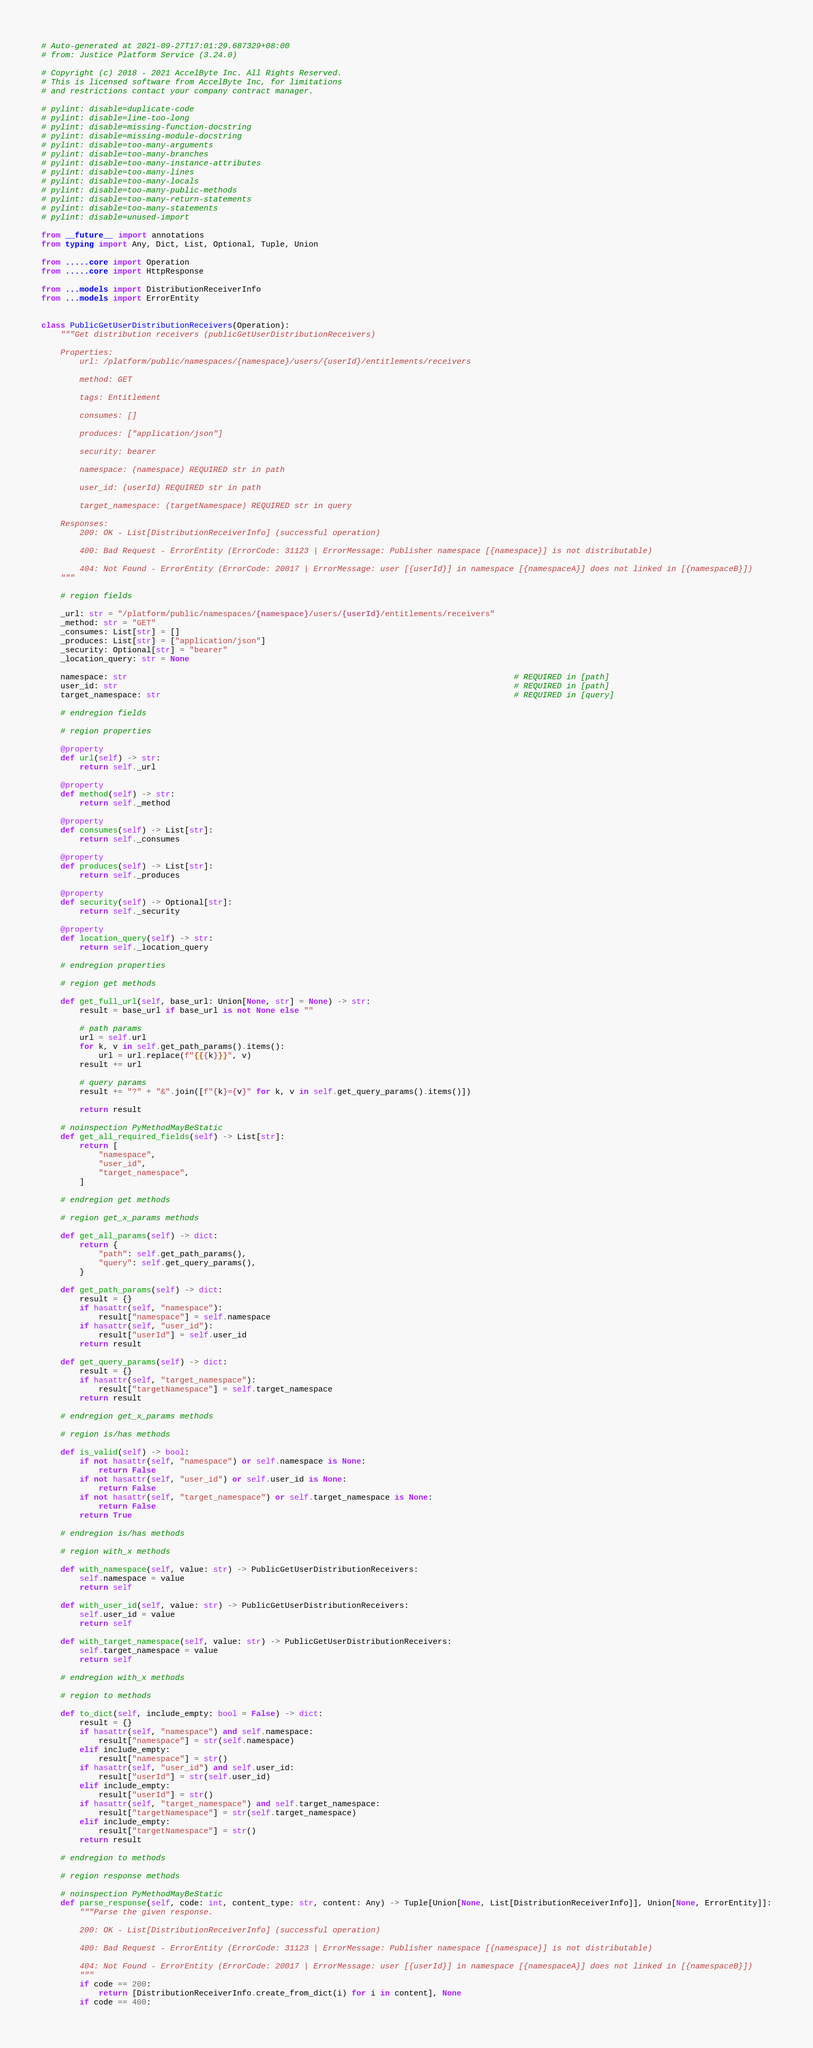<code> <loc_0><loc_0><loc_500><loc_500><_Python_># Auto-generated at 2021-09-27T17:01:29.687329+08:00
# from: Justice Platform Service (3.24.0)

# Copyright (c) 2018 - 2021 AccelByte Inc. All Rights Reserved.
# This is licensed software from AccelByte Inc, for limitations
# and restrictions contact your company contract manager.

# pylint: disable=duplicate-code
# pylint: disable=line-too-long
# pylint: disable=missing-function-docstring
# pylint: disable=missing-module-docstring
# pylint: disable=too-many-arguments
# pylint: disable=too-many-branches
# pylint: disable=too-many-instance-attributes
# pylint: disable=too-many-lines
# pylint: disable=too-many-locals
# pylint: disable=too-many-public-methods
# pylint: disable=too-many-return-statements
# pylint: disable=too-many-statements
# pylint: disable=unused-import

from __future__ import annotations
from typing import Any, Dict, List, Optional, Tuple, Union

from .....core import Operation
from .....core import HttpResponse

from ...models import DistributionReceiverInfo
from ...models import ErrorEntity


class PublicGetUserDistributionReceivers(Operation):
    """Get distribution receivers (publicGetUserDistributionReceivers)

    Properties:
        url: /platform/public/namespaces/{namespace}/users/{userId}/entitlements/receivers

        method: GET

        tags: Entitlement

        consumes: []

        produces: ["application/json"]

        security: bearer

        namespace: (namespace) REQUIRED str in path

        user_id: (userId) REQUIRED str in path

        target_namespace: (targetNamespace) REQUIRED str in query

    Responses:
        200: OK - List[DistributionReceiverInfo] (successful operation)

        400: Bad Request - ErrorEntity (ErrorCode: 31123 | ErrorMessage: Publisher namespace [{namespace}] is not distributable)

        404: Not Found - ErrorEntity (ErrorCode: 20017 | ErrorMessage: user [{userId}] in namespace [{namespaceA}] does not linked in [{namespaceB}])
    """

    # region fields

    _url: str = "/platform/public/namespaces/{namespace}/users/{userId}/entitlements/receivers"
    _method: str = "GET"
    _consumes: List[str] = []
    _produces: List[str] = ["application/json"]
    _security: Optional[str] = "bearer"
    _location_query: str = None

    namespace: str                                                                                 # REQUIRED in [path]
    user_id: str                                                                                   # REQUIRED in [path]
    target_namespace: str                                                                          # REQUIRED in [query]

    # endregion fields

    # region properties

    @property
    def url(self) -> str:
        return self._url

    @property
    def method(self) -> str:
        return self._method

    @property
    def consumes(self) -> List[str]:
        return self._consumes

    @property
    def produces(self) -> List[str]:
        return self._produces

    @property
    def security(self) -> Optional[str]:
        return self._security

    @property
    def location_query(self) -> str:
        return self._location_query

    # endregion properties

    # region get methods

    def get_full_url(self, base_url: Union[None, str] = None) -> str:
        result = base_url if base_url is not None else ""

        # path params
        url = self.url
        for k, v in self.get_path_params().items():
            url = url.replace(f"{{{k}}}", v)
        result += url

        # query params
        result += "?" + "&".join([f"{k}={v}" for k, v in self.get_query_params().items()])

        return result

    # noinspection PyMethodMayBeStatic
    def get_all_required_fields(self) -> List[str]:
        return [
            "namespace",
            "user_id",
            "target_namespace",
        ]

    # endregion get methods

    # region get_x_params methods

    def get_all_params(self) -> dict:
        return {
            "path": self.get_path_params(),
            "query": self.get_query_params(),
        }

    def get_path_params(self) -> dict:
        result = {}
        if hasattr(self, "namespace"):
            result["namespace"] = self.namespace
        if hasattr(self, "user_id"):
            result["userId"] = self.user_id
        return result

    def get_query_params(self) -> dict:
        result = {}
        if hasattr(self, "target_namespace"):
            result["targetNamespace"] = self.target_namespace
        return result

    # endregion get_x_params methods

    # region is/has methods

    def is_valid(self) -> bool:
        if not hasattr(self, "namespace") or self.namespace is None:
            return False
        if not hasattr(self, "user_id") or self.user_id is None:
            return False
        if not hasattr(self, "target_namespace") or self.target_namespace is None:
            return False
        return True

    # endregion is/has methods

    # region with_x methods

    def with_namespace(self, value: str) -> PublicGetUserDistributionReceivers:
        self.namespace = value
        return self

    def with_user_id(self, value: str) -> PublicGetUserDistributionReceivers:
        self.user_id = value
        return self

    def with_target_namespace(self, value: str) -> PublicGetUserDistributionReceivers:
        self.target_namespace = value
        return self

    # endregion with_x methods

    # region to methods

    def to_dict(self, include_empty: bool = False) -> dict:
        result = {}
        if hasattr(self, "namespace") and self.namespace:
            result["namespace"] = str(self.namespace)
        elif include_empty:
            result["namespace"] = str()
        if hasattr(self, "user_id") and self.user_id:
            result["userId"] = str(self.user_id)
        elif include_empty:
            result["userId"] = str()
        if hasattr(self, "target_namespace") and self.target_namespace:
            result["targetNamespace"] = str(self.target_namespace)
        elif include_empty:
            result["targetNamespace"] = str()
        return result

    # endregion to methods

    # region response methods

    # noinspection PyMethodMayBeStatic
    def parse_response(self, code: int, content_type: str, content: Any) -> Tuple[Union[None, List[DistributionReceiverInfo]], Union[None, ErrorEntity]]:
        """Parse the given response.

        200: OK - List[DistributionReceiverInfo] (successful operation)

        400: Bad Request - ErrorEntity (ErrorCode: 31123 | ErrorMessage: Publisher namespace [{namespace}] is not distributable)

        404: Not Found - ErrorEntity (ErrorCode: 20017 | ErrorMessage: user [{userId}] in namespace [{namespaceA}] does not linked in [{namespaceB}])
        """
        if code == 200:
            return [DistributionReceiverInfo.create_from_dict(i) for i in content], None
        if code == 400:</code> 